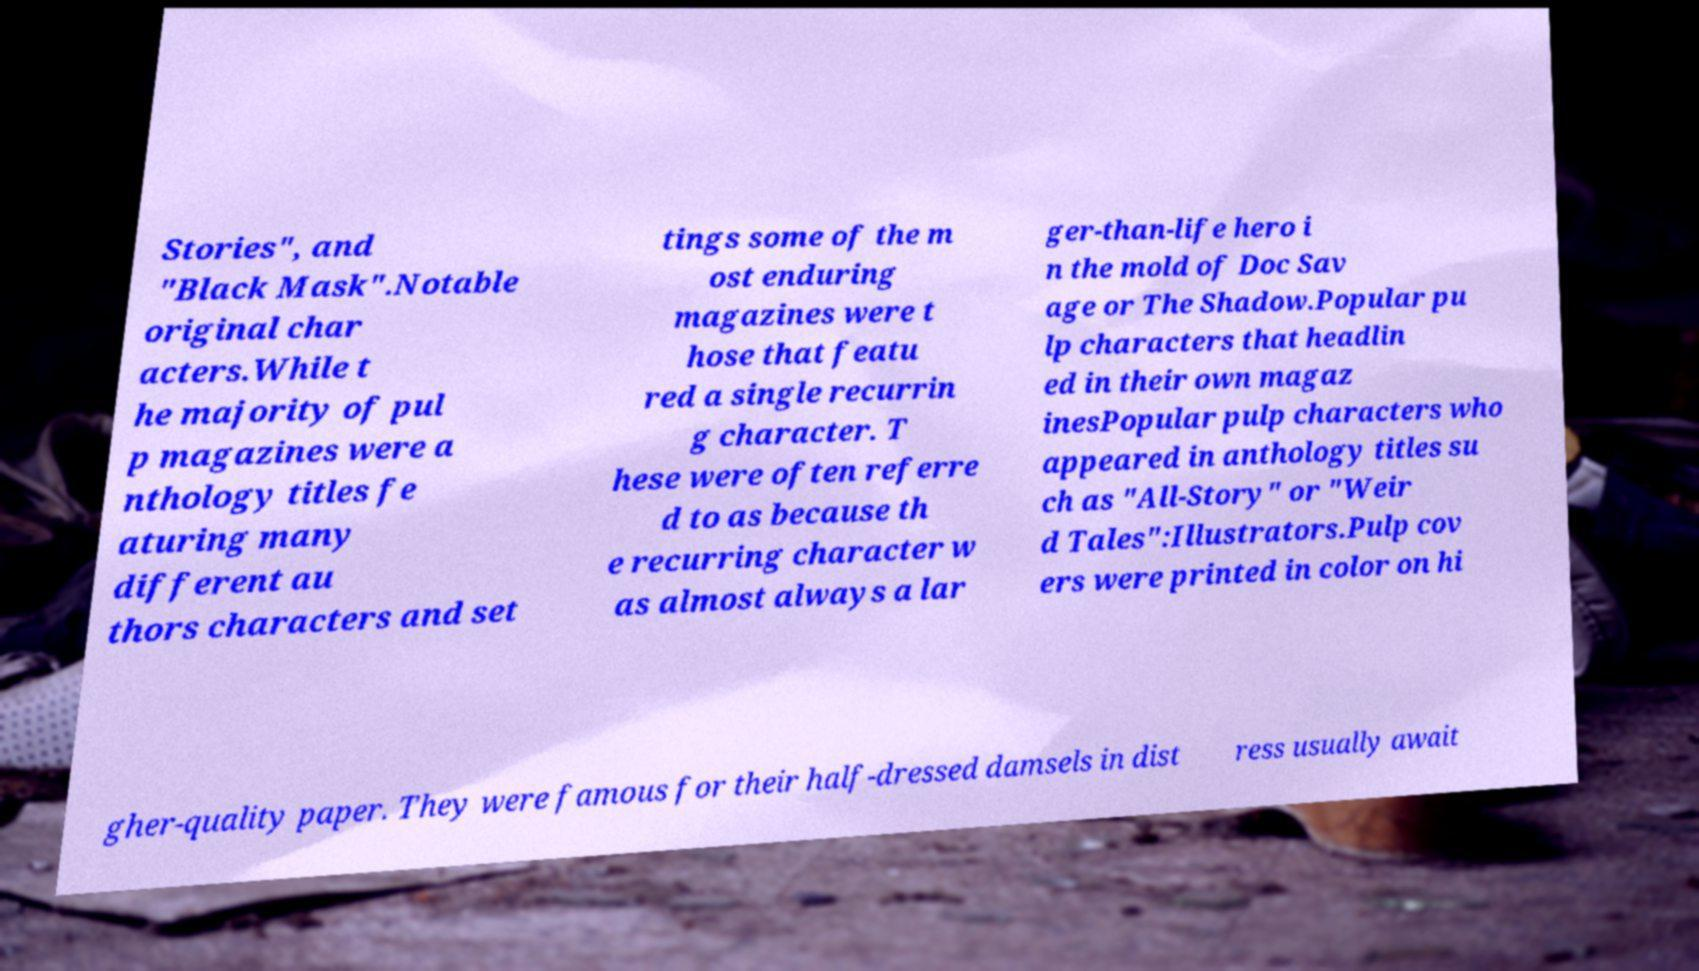What messages or text are displayed in this image? I need them in a readable, typed format. Stories", and "Black Mask".Notable original char acters.While t he majority of pul p magazines were a nthology titles fe aturing many different au thors characters and set tings some of the m ost enduring magazines were t hose that featu red a single recurrin g character. T hese were often referre d to as because th e recurring character w as almost always a lar ger-than-life hero i n the mold of Doc Sav age or The Shadow.Popular pu lp characters that headlin ed in their own magaz inesPopular pulp characters who appeared in anthology titles su ch as "All-Story" or "Weir d Tales":Illustrators.Pulp cov ers were printed in color on hi gher-quality paper. They were famous for their half-dressed damsels in dist ress usually await 